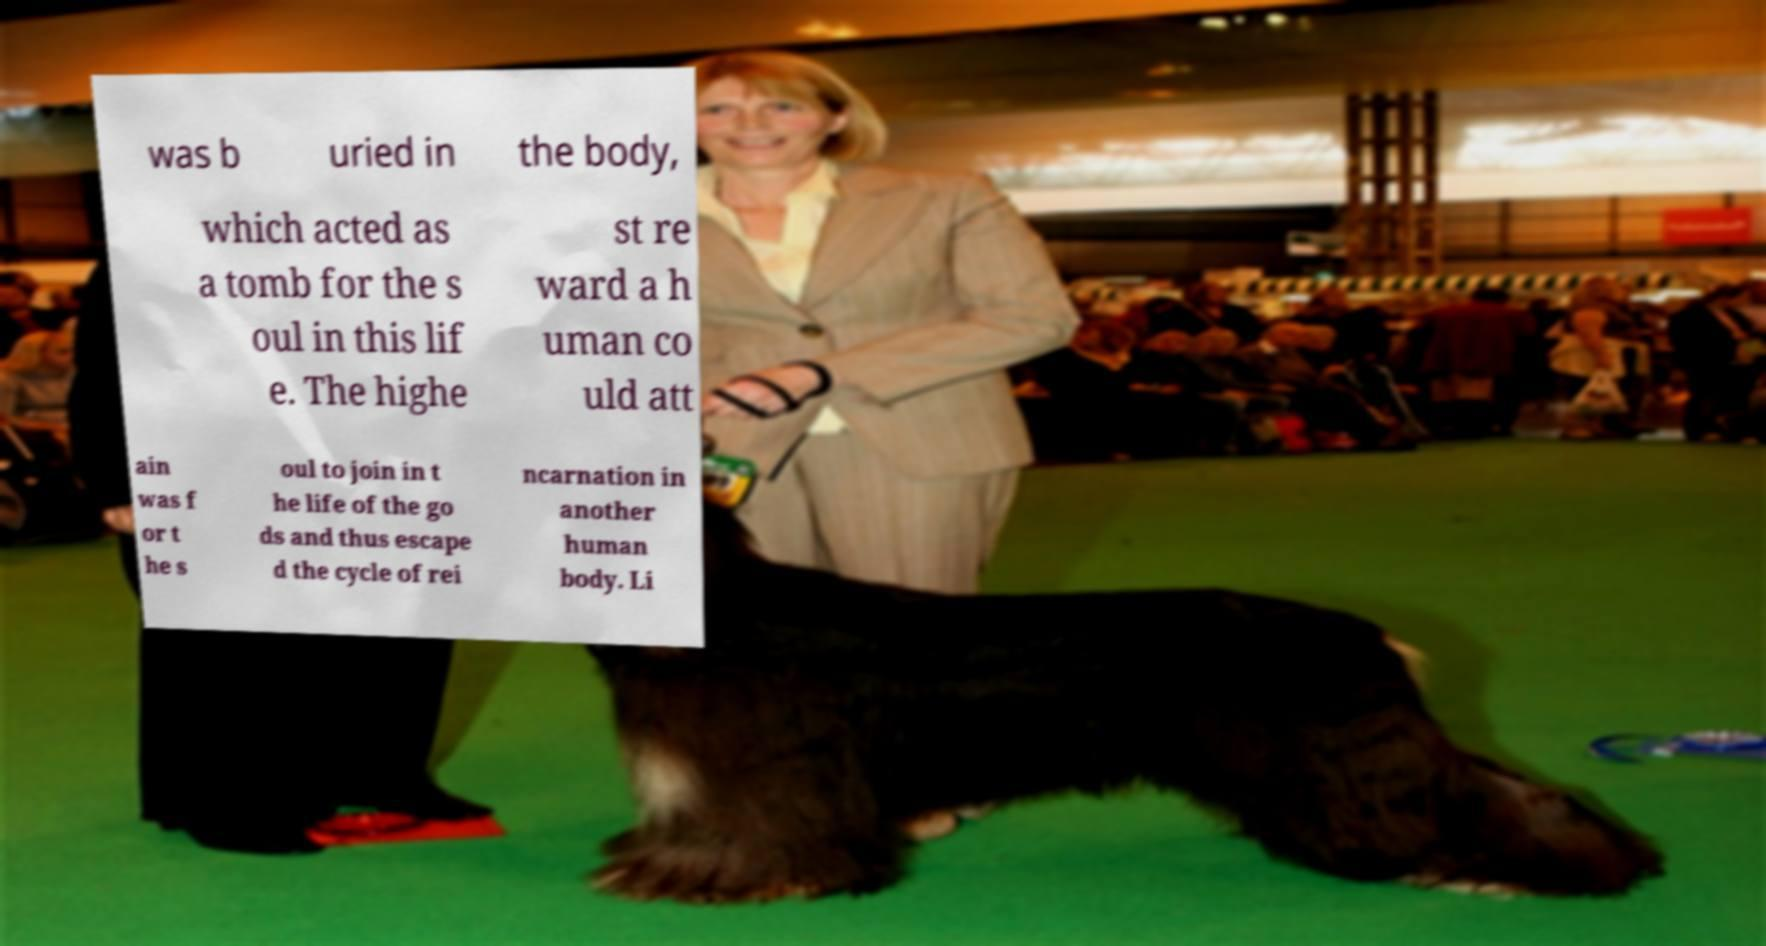There's text embedded in this image that I need extracted. Can you transcribe it verbatim? was b uried in the body, which acted as a tomb for the s oul in this lif e. The highe st re ward a h uman co uld att ain was f or t he s oul to join in t he life of the go ds and thus escape d the cycle of rei ncarnation in another human body. Li 